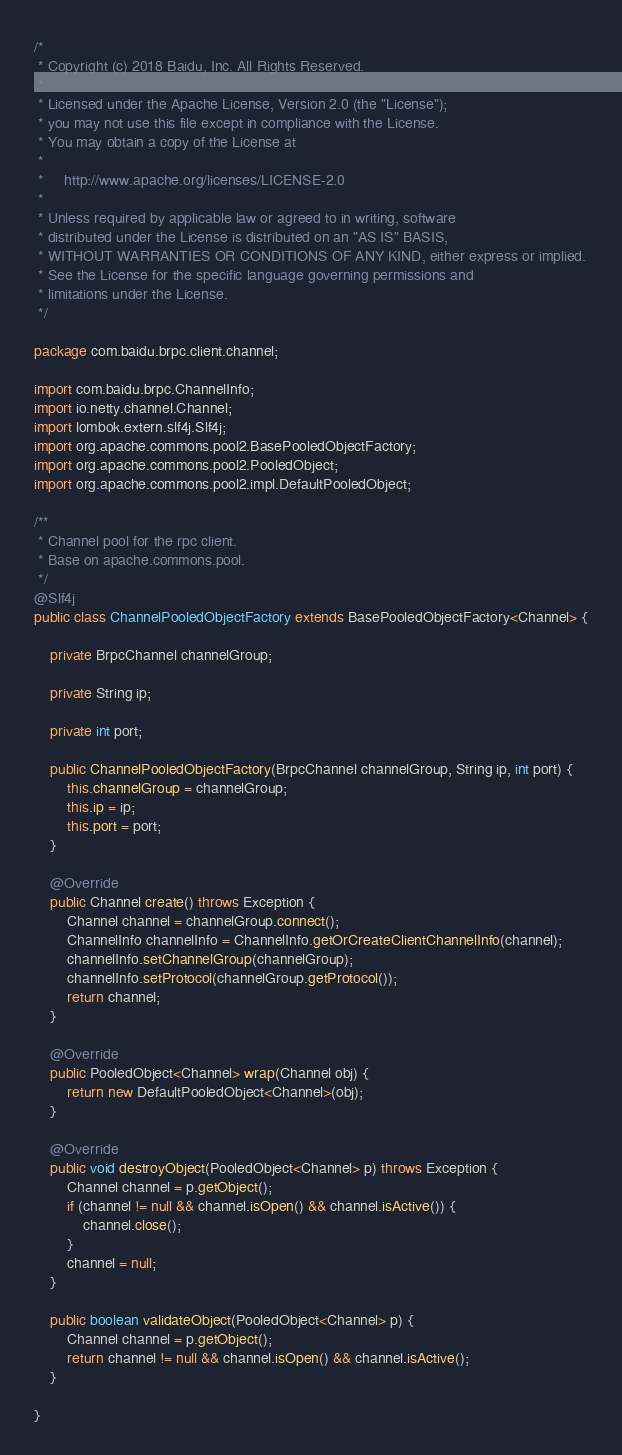<code> <loc_0><loc_0><loc_500><loc_500><_Java_>/*
 * Copyright (c) 2018 Baidu, Inc. All Rights Reserved.
 *
 * Licensed under the Apache License, Version 2.0 (the "License");
 * you may not use this file except in compliance with the License.
 * You may obtain a copy of the License at
 *
 *     http://www.apache.org/licenses/LICENSE-2.0
 *
 * Unless required by applicable law or agreed to in writing, software
 * distributed under the License is distributed on an "AS IS" BASIS,
 * WITHOUT WARRANTIES OR CONDITIONS OF ANY KIND, either express or implied.
 * See the License for the specific language governing permissions and
 * limitations under the License.
 */

package com.baidu.brpc.client.channel;

import com.baidu.brpc.ChannelInfo;
import io.netty.channel.Channel;
import lombok.extern.slf4j.Slf4j;
import org.apache.commons.pool2.BasePooledObjectFactory;
import org.apache.commons.pool2.PooledObject;
import org.apache.commons.pool2.impl.DefaultPooledObject;

/**
 * Channel pool for the rpc client.
 * Base on apache.commons.pool.
 */
@Slf4j
public class ChannelPooledObjectFactory extends BasePooledObjectFactory<Channel> {

    private BrpcChannel channelGroup;

    private String ip;

    private int port;

    public ChannelPooledObjectFactory(BrpcChannel channelGroup, String ip, int port) {
        this.channelGroup = channelGroup;
        this.ip = ip;
        this.port = port;
    }

    @Override
    public Channel create() throws Exception {
        Channel channel = channelGroup.connect();
        ChannelInfo channelInfo = ChannelInfo.getOrCreateClientChannelInfo(channel);
        channelInfo.setChannelGroup(channelGroup);
        channelInfo.setProtocol(channelGroup.getProtocol());
        return channel;
    }

    @Override
    public PooledObject<Channel> wrap(Channel obj) {
        return new DefaultPooledObject<Channel>(obj);
    }

    @Override
    public void destroyObject(PooledObject<Channel> p) throws Exception {
        Channel channel = p.getObject();
        if (channel != null && channel.isOpen() && channel.isActive()) {
            channel.close();
        }
        channel = null;
    }

    public boolean validateObject(PooledObject<Channel> p) {
        Channel channel = p.getObject();
        return channel != null && channel.isOpen() && channel.isActive();
    }

}</code> 